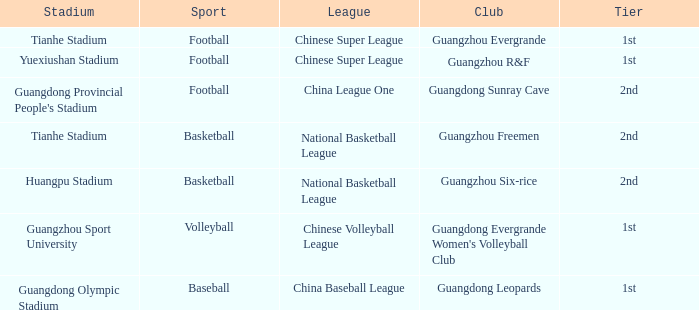Which tier is for football at Tianhe Stadium? 1st. 